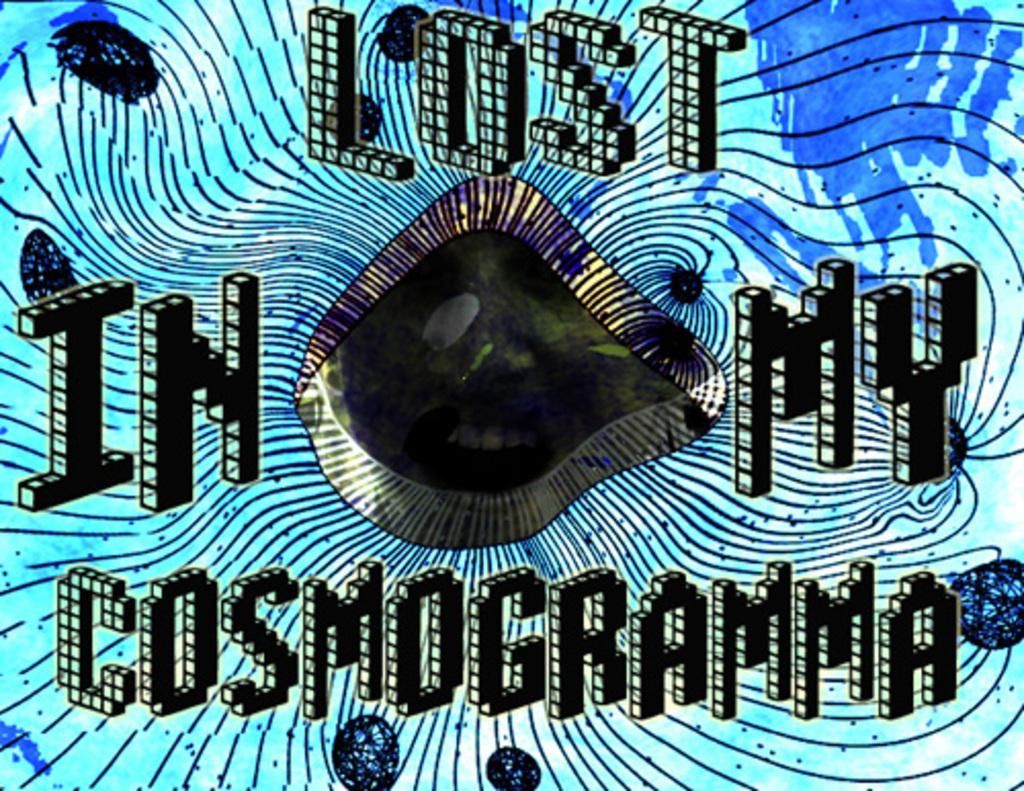<image>
Summarize the visual content of the image. A work of art with the caption Lost in my cosmogramma. 